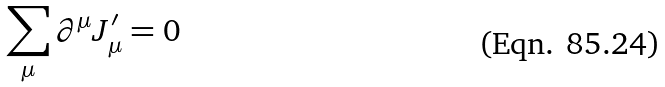Convert formula to latex. <formula><loc_0><loc_0><loc_500><loc_500>\sum _ { \mu } \partial ^ { \mu } J ^ { \prime } _ { \mu } = 0</formula> 